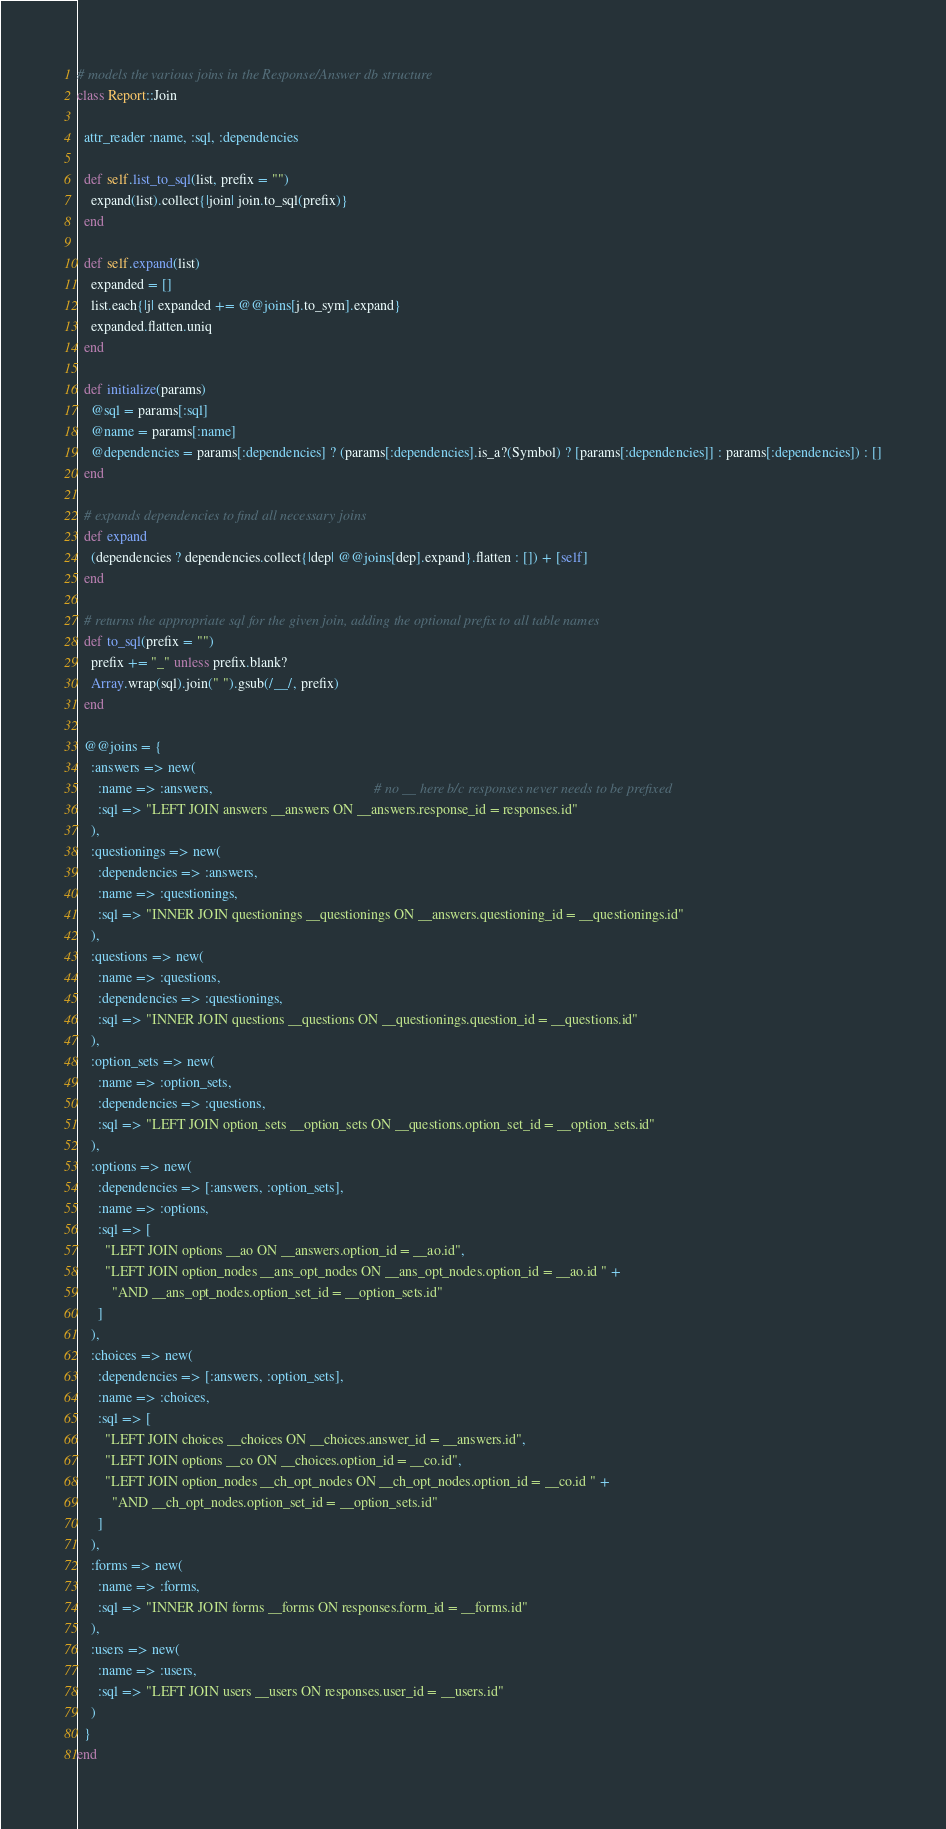Convert code to text. <code><loc_0><loc_0><loc_500><loc_500><_Ruby_># models the various joins in the Response/Answer db structure
class Report::Join

  attr_reader :name, :sql, :dependencies

  def self.list_to_sql(list, prefix = "")
    expand(list).collect{|join| join.to_sql(prefix)}
  end

  def self.expand(list)
    expanded = []
    list.each{|j| expanded += @@joins[j.to_sym].expand}
    expanded.flatten.uniq
  end

  def initialize(params)
    @sql = params[:sql]
    @name = params[:name]
    @dependencies = params[:dependencies] ? (params[:dependencies].is_a?(Symbol) ? [params[:dependencies]] : params[:dependencies]) : []
  end

  # expands dependencies to find all necessary joins
  def expand
    (dependencies ? dependencies.collect{|dep| @@joins[dep].expand}.flatten : []) + [self]
  end

  # returns the appropriate sql for the given join, adding the optional prefix to all table names
  def to_sql(prefix = "")
    prefix += "_" unless prefix.blank?
    Array.wrap(sql).join(" ").gsub(/__/, prefix)
  end

  @@joins = {
    :answers => new(
      :name => :answers,                                              # no __ here b/c responses never needs to be prefixed
      :sql => "LEFT JOIN answers __answers ON __answers.response_id = responses.id"
    ),
    :questionings => new(
      :dependencies => :answers,
      :name => :questionings,
      :sql => "INNER JOIN questionings __questionings ON __answers.questioning_id = __questionings.id"
    ),
    :questions => new(
      :name => :questions,
      :dependencies => :questionings,
      :sql => "INNER JOIN questions __questions ON __questionings.question_id = __questions.id"
    ),
    :option_sets => new(
      :name => :option_sets,
      :dependencies => :questions,
      :sql => "LEFT JOIN option_sets __option_sets ON __questions.option_set_id = __option_sets.id"
    ),
    :options => new(
      :dependencies => [:answers, :option_sets],
      :name => :options,
      :sql => [
        "LEFT JOIN options __ao ON __answers.option_id = __ao.id",
        "LEFT JOIN option_nodes __ans_opt_nodes ON __ans_opt_nodes.option_id = __ao.id " +
          "AND __ans_opt_nodes.option_set_id = __option_sets.id"
      ]
    ),
    :choices => new(
      :dependencies => [:answers, :option_sets],
      :name => :choices,
      :sql => [
        "LEFT JOIN choices __choices ON __choices.answer_id = __answers.id",
        "LEFT JOIN options __co ON __choices.option_id = __co.id",
        "LEFT JOIN option_nodes __ch_opt_nodes ON __ch_opt_nodes.option_id = __co.id " +
          "AND __ch_opt_nodes.option_set_id = __option_sets.id"
      ]
    ),
    :forms => new(
      :name => :forms,
      :sql => "INNER JOIN forms __forms ON responses.form_id = __forms.id"
    ),
    :users => new(
      :name => :users,
      :sql => "LEFT JOIN users __users ON responses.user_id = __users.id"
    )
  }
end</code> 